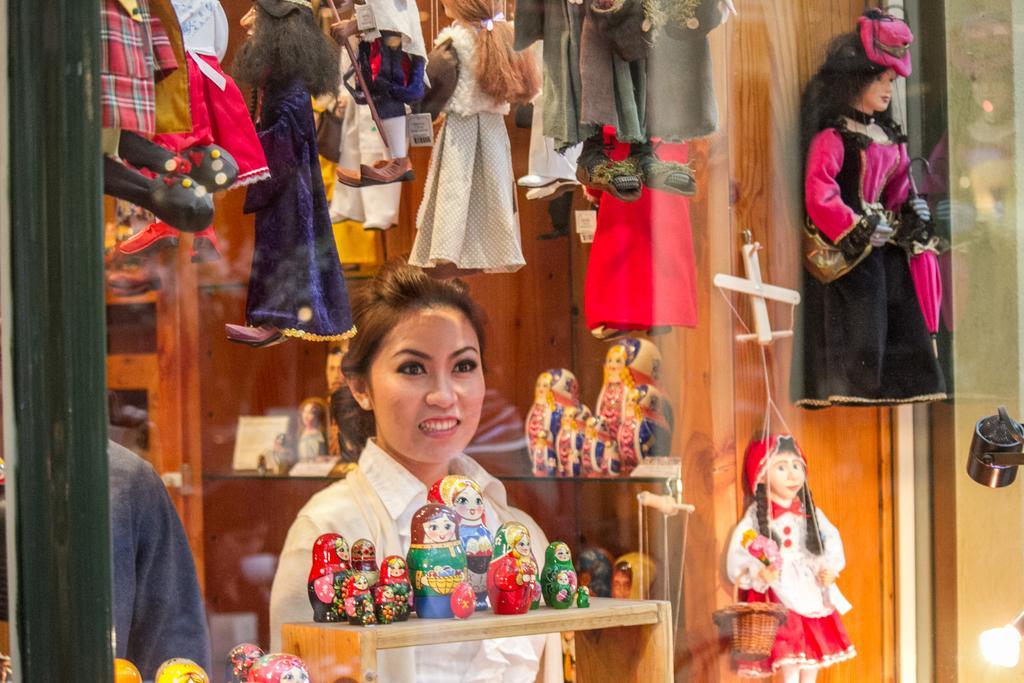Please provide a concise description of this image. In this image there is a woman standing. In front of her there is a table. There are dolls on the table. Beside her there is a person standing. Behind her there are shelves to the wooden wall. There are dolls on the shelf. At the top there are toys hanging. In the bottom right there is a light. 